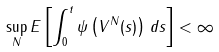<formula> <loc_0><loc_0><loc_500><loc_500>\sup _ { N } E \left [ \int _ { 0 } ^ { t } \psi \left ( V ^ { N } ( s ) \right ) \, d s \right ] < \infty</formula> 